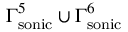<formula> <loc_0><loc_0><loc_500><loc_500>\Gamma _ { s o n i c } ^ { 5 } \cup \Gamma _ { s o n i c } ^ { 6 }</formula> 